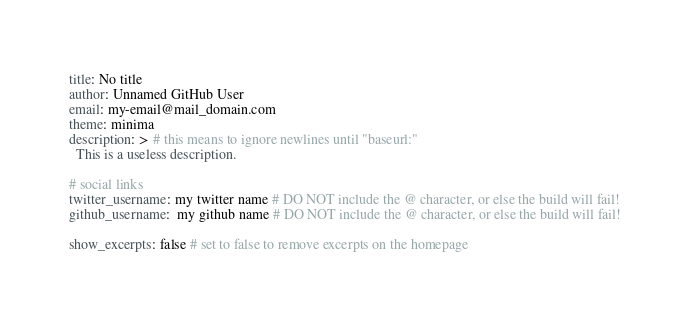Convert code to text. <code><loc_0><loc_0><loc_500><loc_500><_YAML_>title: No title
author: Unnamed GitHub User
email: my-email@mail_domain.com
theme: minima
description: > # this means to ignore newlines until "baseurl:"
  This is a useless description.

# social links
twitter_username: my twitter name # DO NOT include the @ character, or else the build will fail!
github_username:  my github name # DO NOT include the @ character, or else the build will fail!

show_excerpts: false # set to false to remove excerpts on the homepage
</code> 